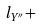Convert formula to latex. <formula><loc_0><loc_0><loc_500><loc_500>l _ { Y ^ { \prime \prime } } +</formula> 